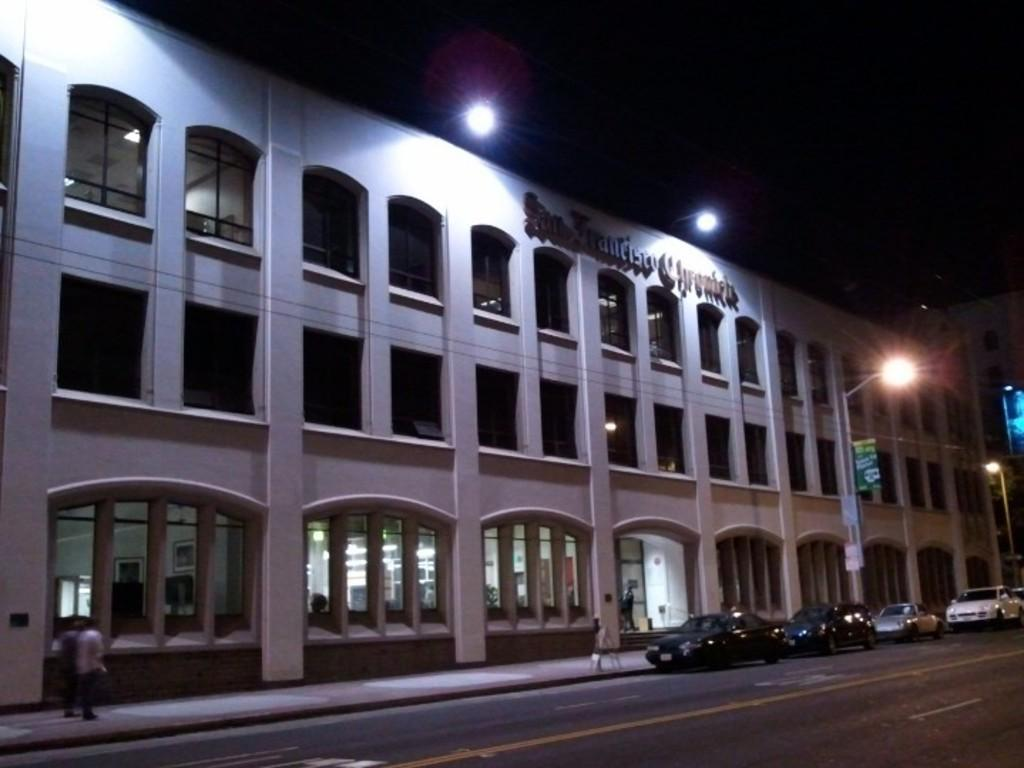What is the main feature of the image? There is a road in the image. What is happening on the road? There are cars on the road. Is there any pedestrian infrastructure visible in the image? Yes, there is a footpath near the cars. What are the people on the footpath doing? People are walking on the footpath. What can be seen in the background of the image? There is a building in the background of the image. What type of coil is being used by the people walking on the footpath? There is no coil present in the image; people are simply walking on the footpath. Can you tell me the flavor of the berries being consumed by the cars? Cars do not consume berries, and there are no berries present in the image. 